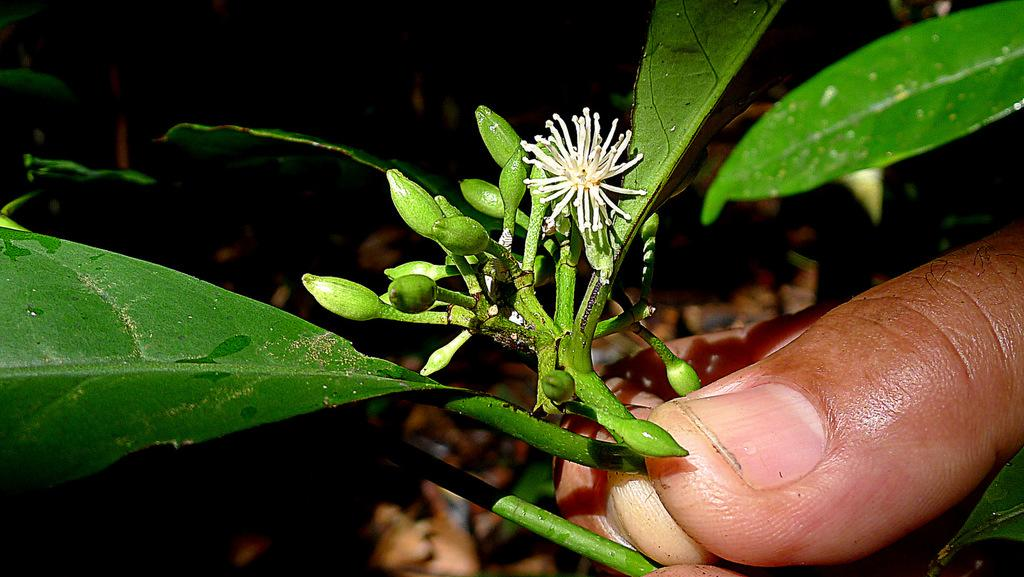What is visible at the bottom of the image? There are fingers visible at the bottom of the image. What is growing on the fingers? There are plants and flowers in the fingers. Can you tell me how many tomatoes are growing on the fingers in the image? There are no tomatoes present in the image; it features plants and flowers. How many boys are visible in the image? There are no boys visible in the image; it only shows fingers with plants and flowers. 